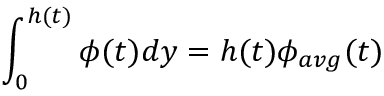<formula> <loc_0><loc_0><loc_500><loc_500>\int _ { 0 } ^ { h ( t ) } \phi ( t ) d y = h ( t ) \phi _ { a v g } ( t )</formula> 